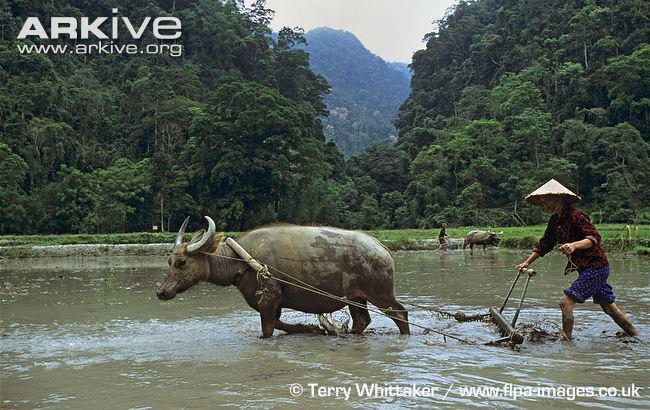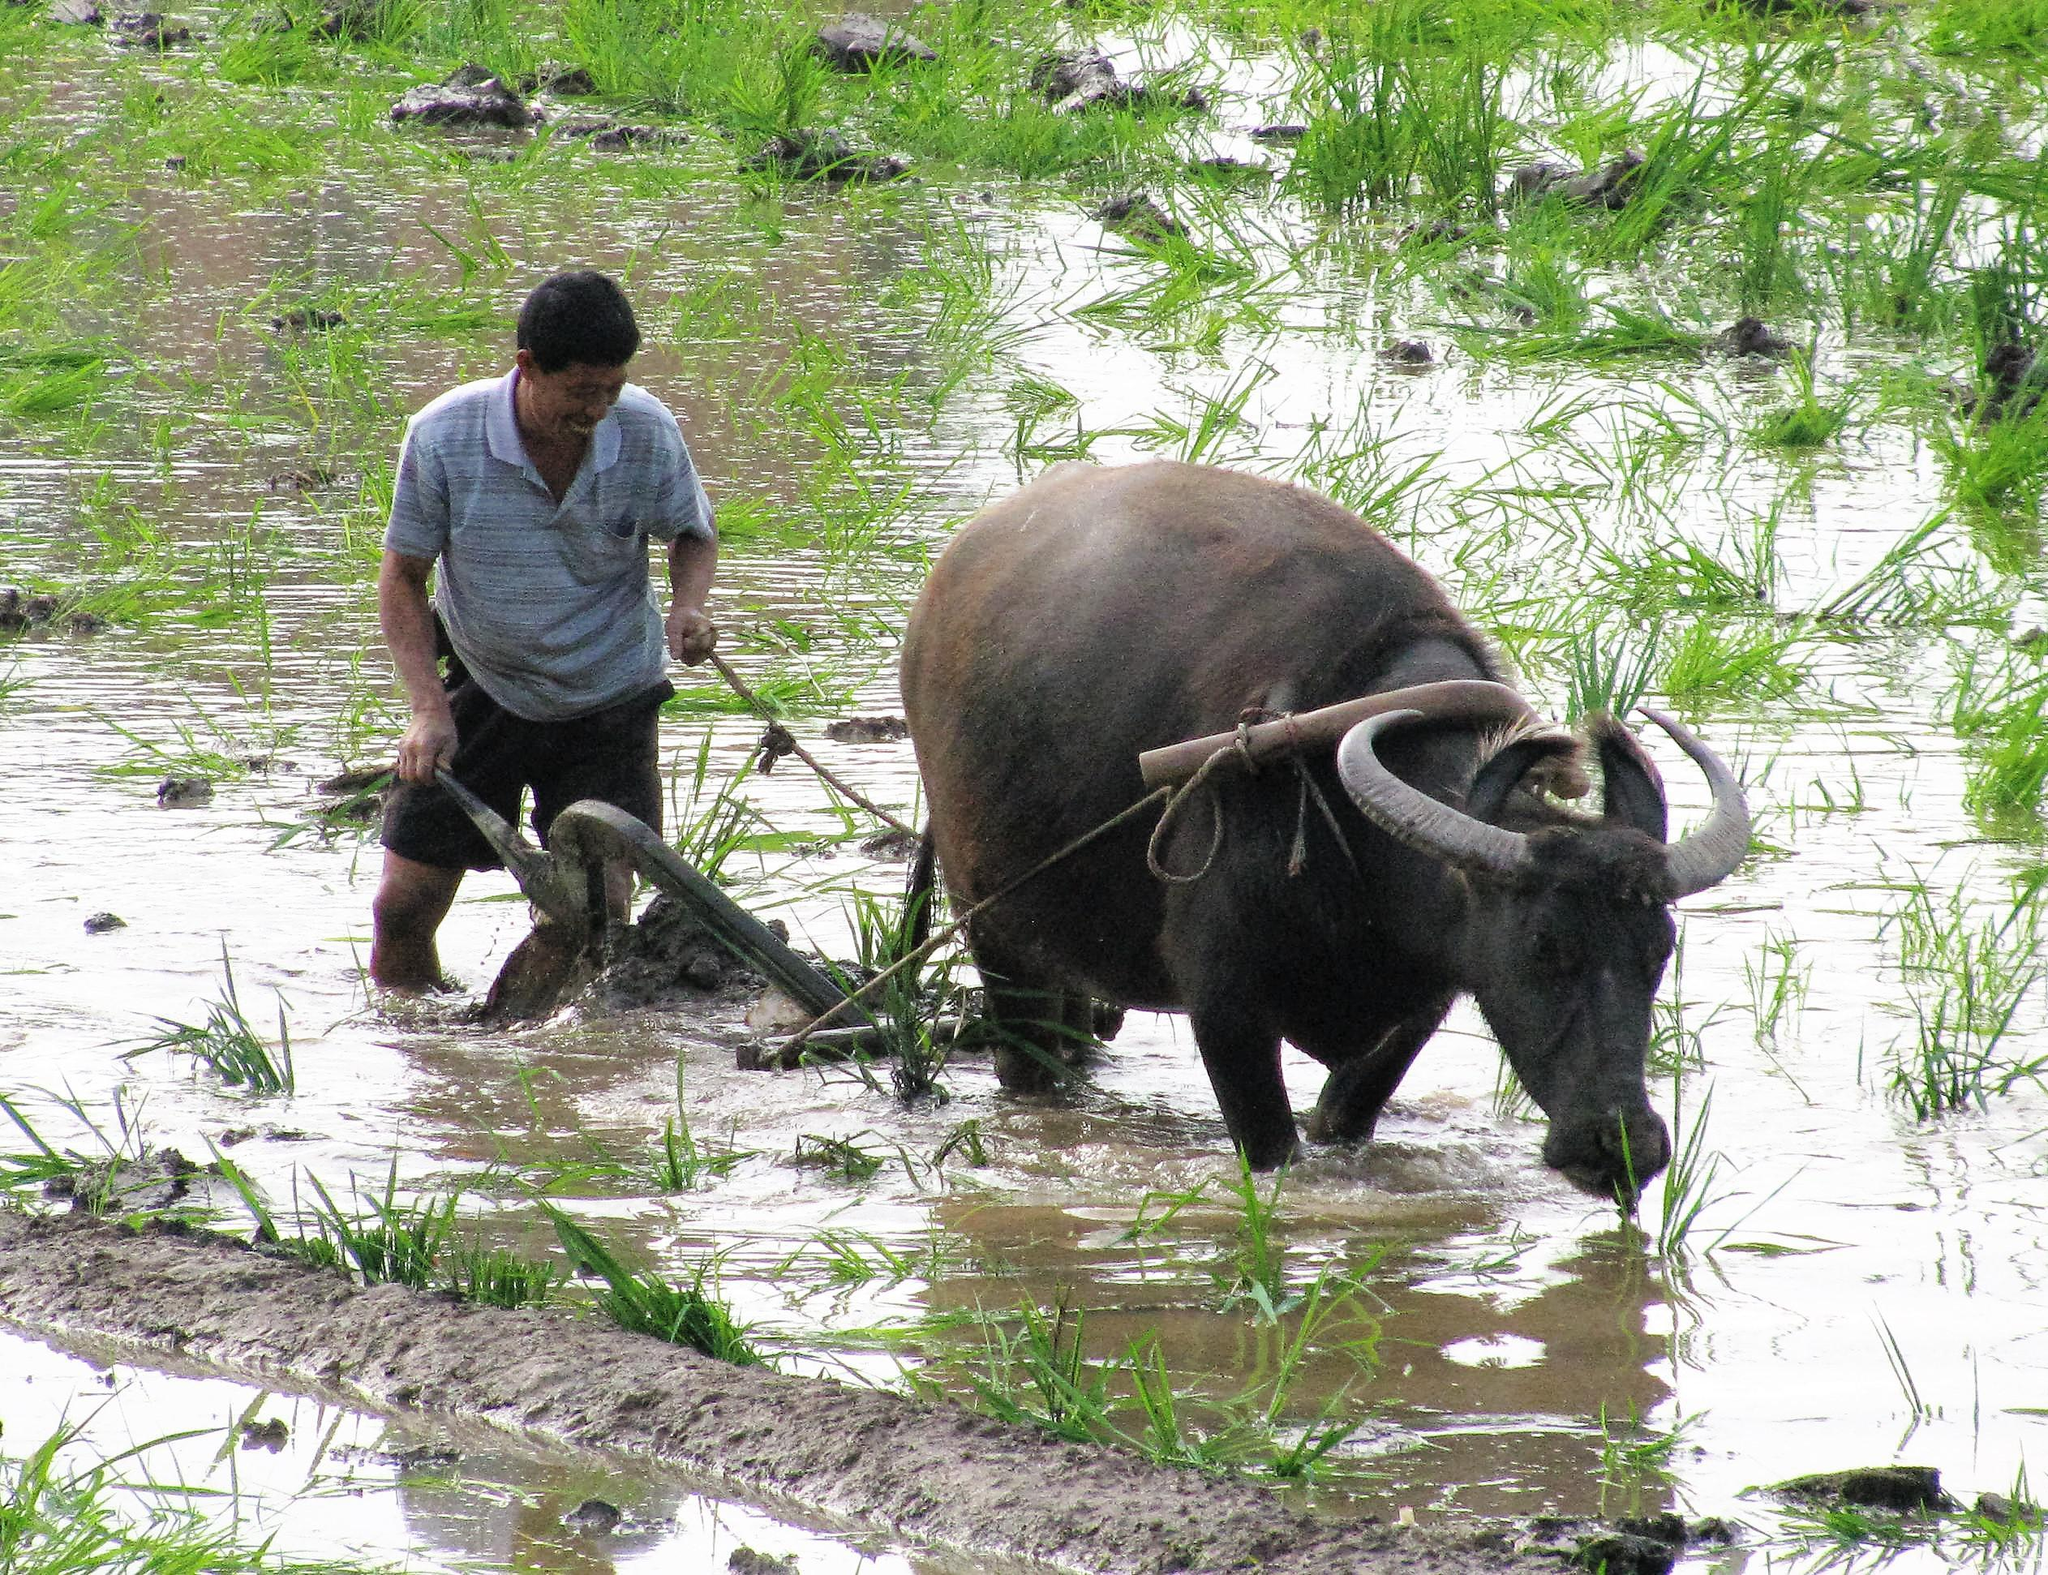The first image is the image on the left, the second image is the image on the right. Examine the images to the left and right. Is the description "There is no more than one water buffalo in the right image." accurate? Answer yes or no. Yes. The first image is the image on the left, the second image is the image on the right. Considering the images on both sides, is "At least one image shows a team of two oxen pulling a plow with a man behind it." valid? Answer yes or no. No. 